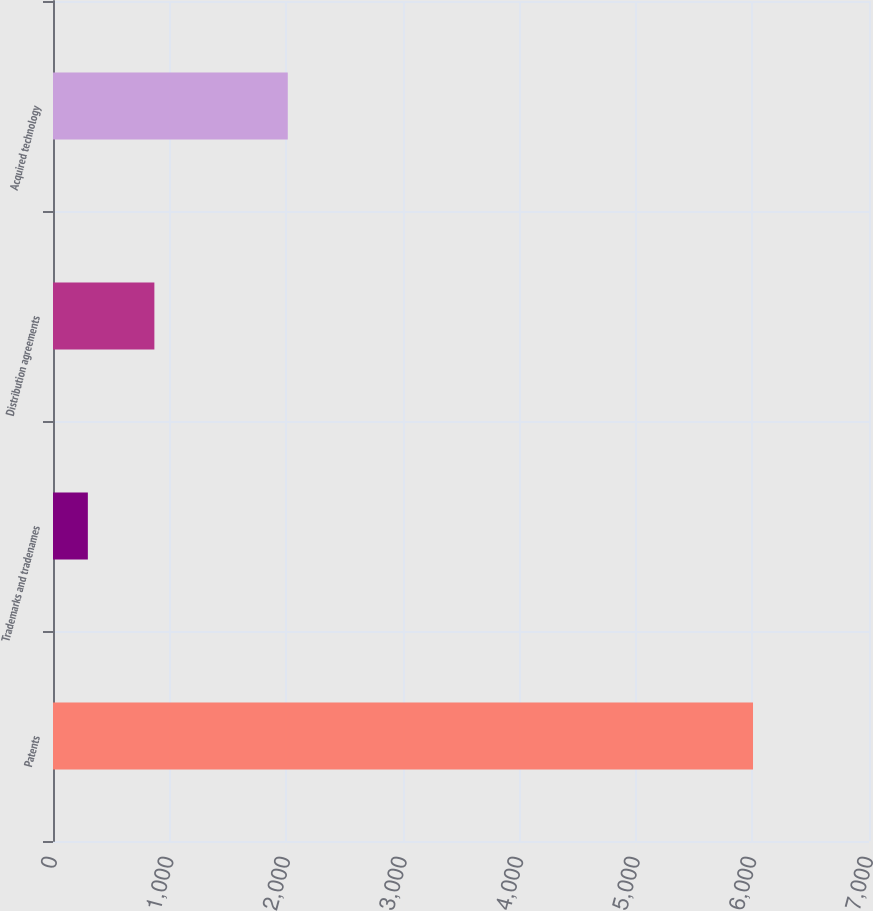<chart> <loc_0><loc_0><loc_500><loc_500><bar_chart><fcel>Patents<fcel>Trademarks and tradenames<fcel>Distribution agreements<fcel>Acquired technology<nl><fcel>6005<fcel>299<fcel>869.6<fcel>2014<nl></chart> 